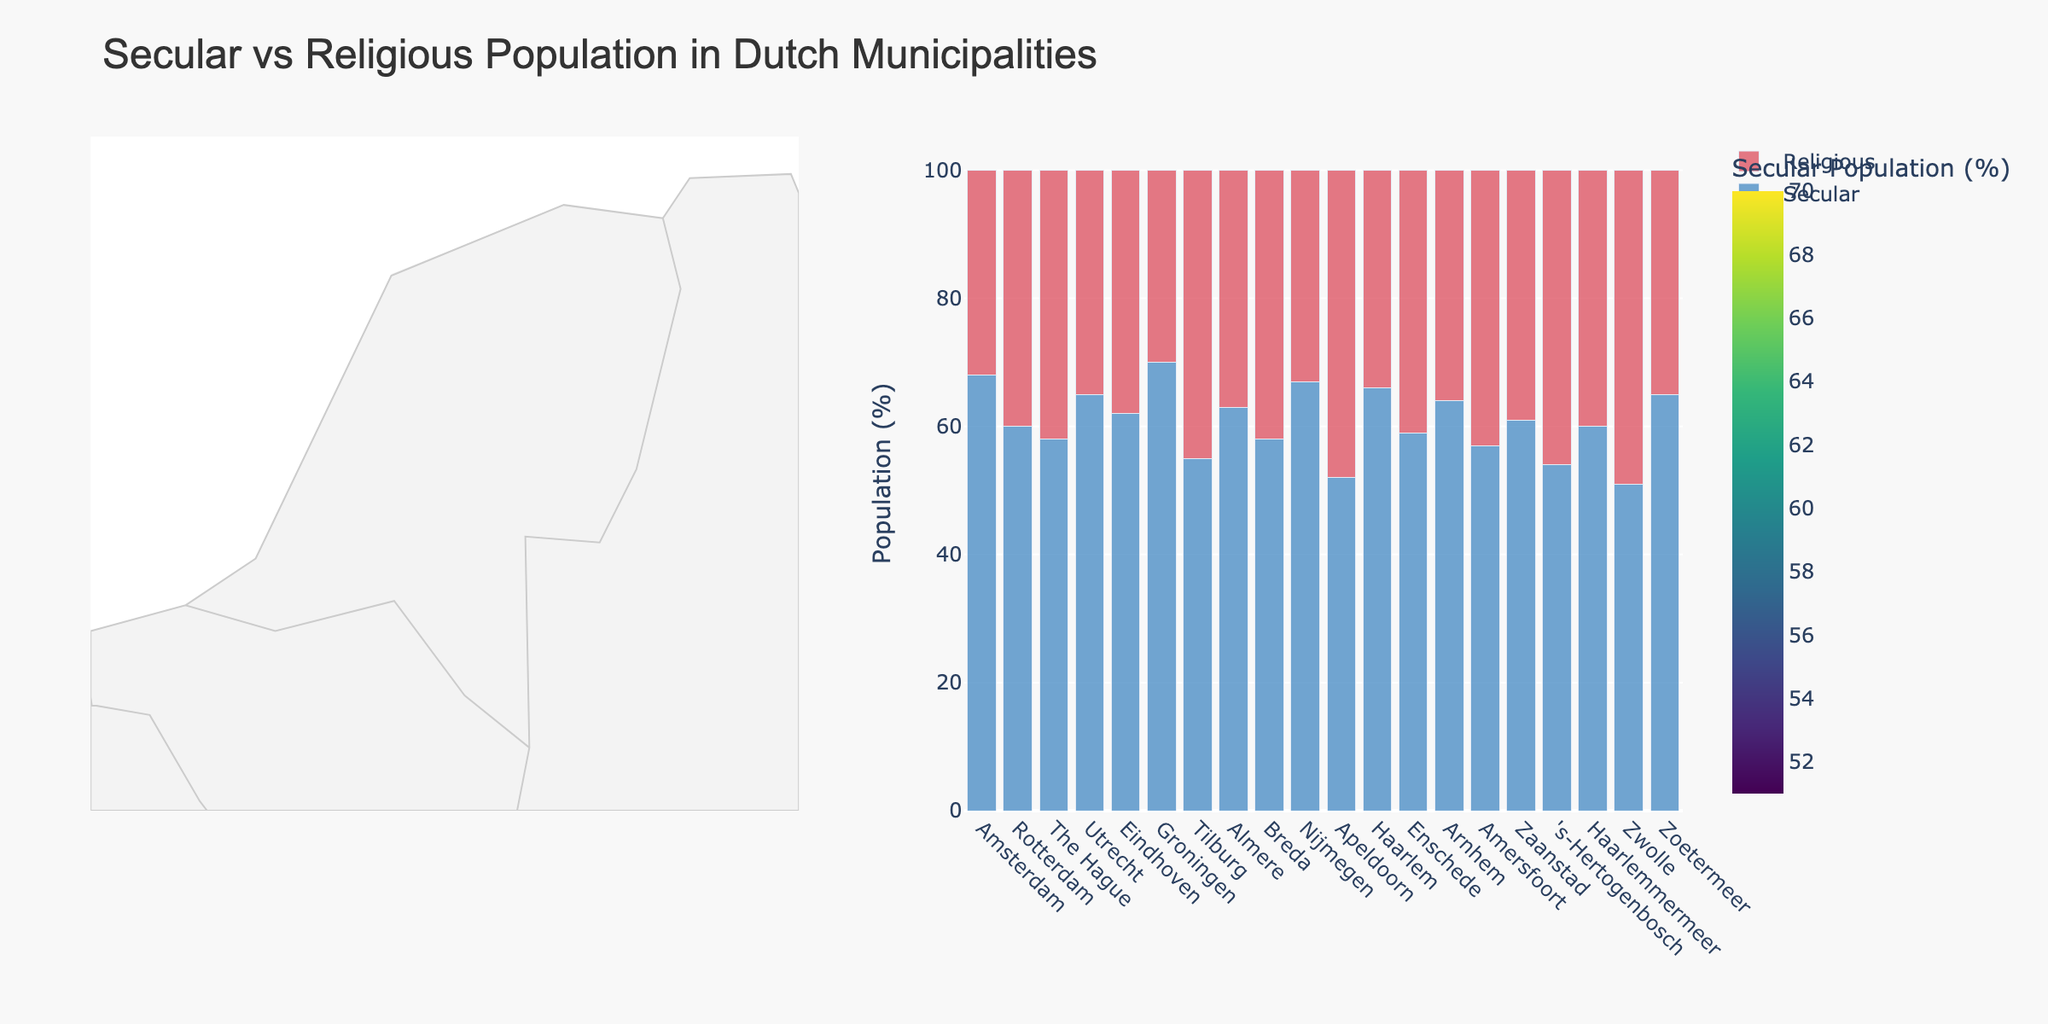What is the title of the figure? The title is located at the top of the figure and provides a brief description of what the figure is about.
Answer: Secular vs Religious Population in Dutch Municipalities Which municipality has the highest percentage of secular population? To find this, look at the bar chart and note the municipality with the tallest bar in the "Secular" color.
Answer: Groningen What is the percentage difference between the secular and religious populations in Zwolle? Locate Zwolle in the bar chart and subtract the percentage of religious population from the percentage of secular population.
Answer: 2% Which municipality has the most balanced distribution between secular and religious populations? A balanced distribution means the percentages of secular and religious populations are closest to each other. Find the municipality where the two bars are almost equal in height.
Answer: Zwolle Which municipalities have a secular population greater than 60%? Look at the bar chart and identify all municipalities with bars (secular) taller than 60%.
Answer: Amsterdam, Rotterdam, Utrecht, Eindhoven, Groningen, Almere, Nijmegen, Haarlem, Zoetermeer Rank the municipalities with the lowest to the highest secular population. Examine the bar chart to rank municipalities by the height of the secular population bars from shortest to tallest.
Answer: Zwolle, Apeldoorn, 's-Hertogenbosch, Tilburg, Amersfoort, Breda, The Hague, Enschede, Haarlemmermeer, Zaanstad, Rotterdam, Haarlemmermeer, Almere, Arnhem, Utrecht, Eindhoven, Zoetermeer, Haarlem, Nijmegen, Amsterdam, Groningen Which municipality has the largest gap between secular and religious populations? Identify the municipality with the biggest difference between the heights of the "Secular" and "Religious" bars.
Answer: Groningen In which part of the Netherlands (North, South, East, West) are secular populations generally higher based on the map? Observe the geographic distribution and color intensities on the choropleth map to identify regions with generally higher secular populations.
Answer: West and North What is the total percentage of the population identified as secular across the given municipalities? Add the percentages of the secular populations across all municipalities.
Answer: 1073% Which municipality has the highest percentage of religious population? Identify in the bar chart the municipality with the tallest bar in the "Religious" color.
Answer: Zwolle 